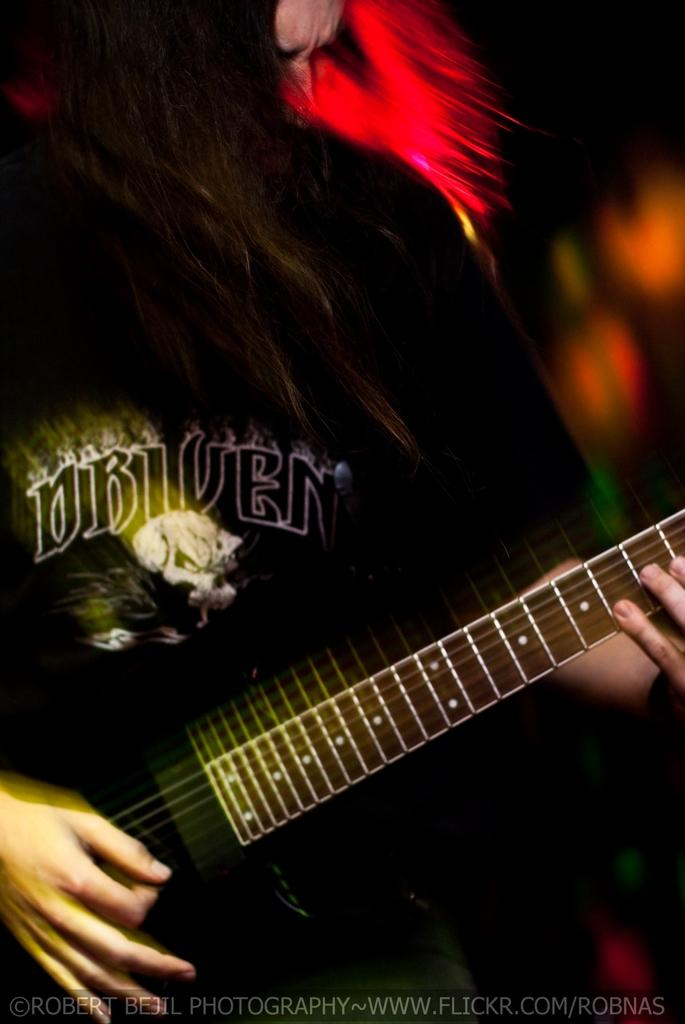What is the main subject of the image? There is a person in the image. What is the person holding in the image? The person is holding a guitar. Can you describe the background of the image? The background of the image is blurred. Is there any text present in the image? Yes, there is some text at the bottom of the image. What type of plants can be seen growing on the floor in the image? There are no plants visible in the image, and the floor is not mentioned in the provided facts. 